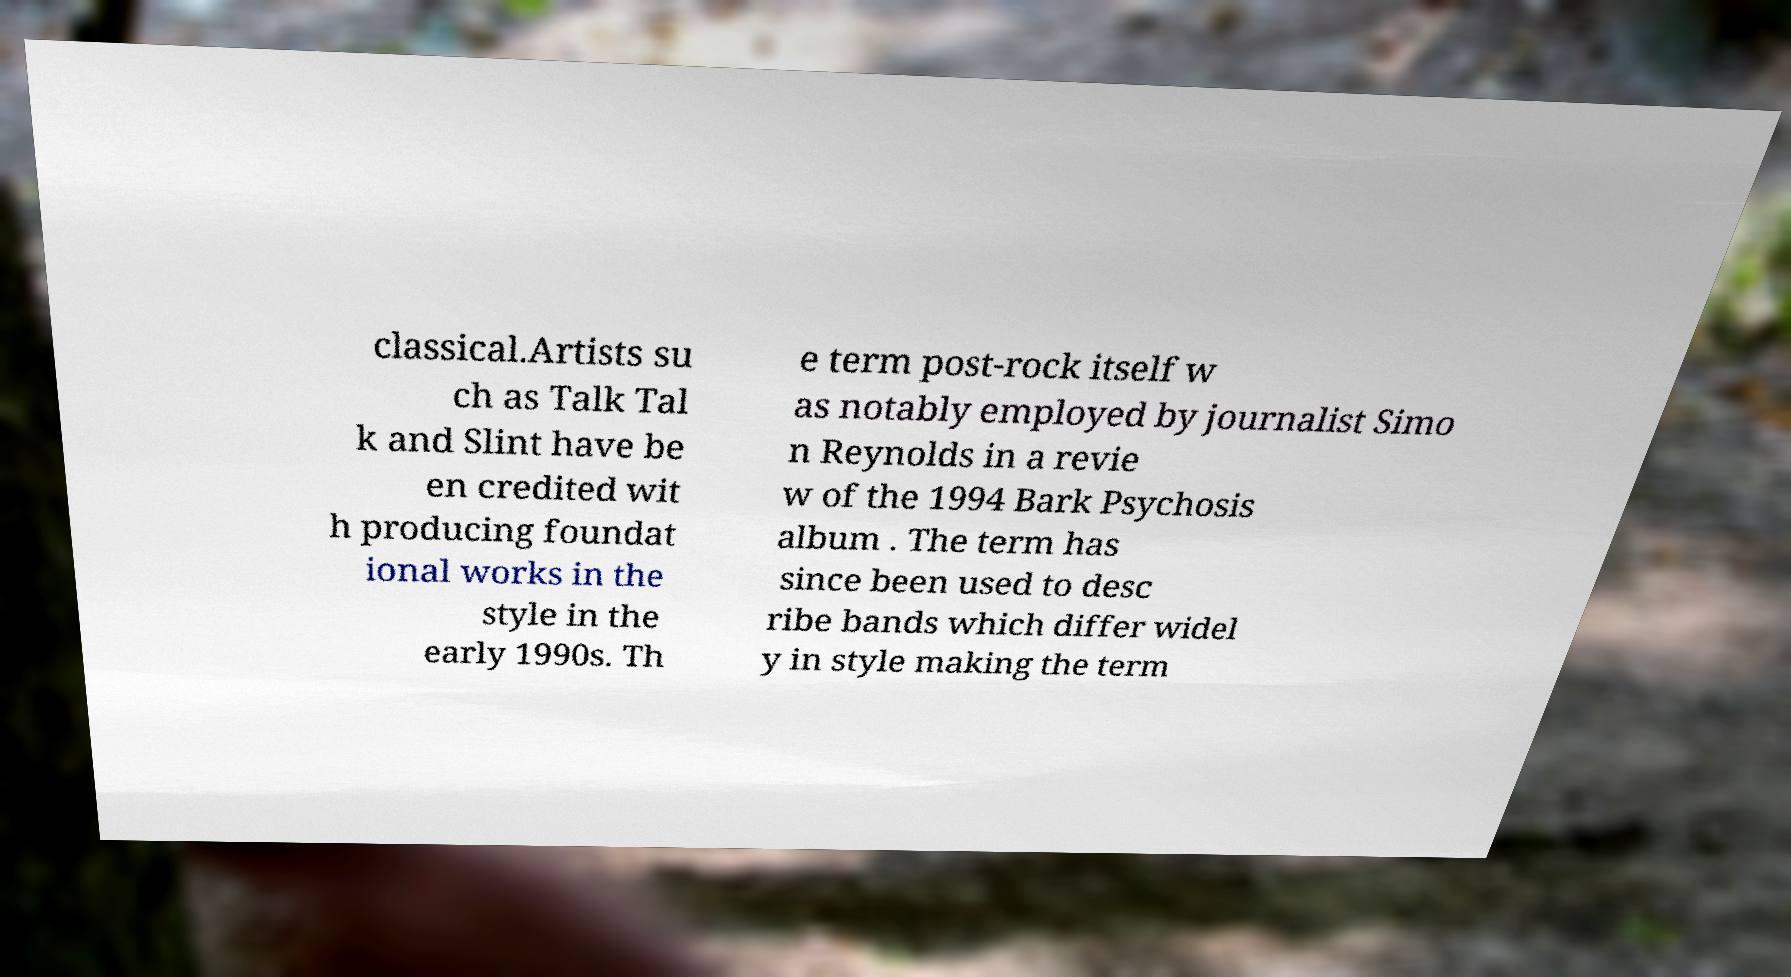Can you read and provide the text displayed in the image?This photo seems to have some interesting text. Can you extract and type it out for me? classical.Artists su ch as Talk Tal k and Slint have be en credited wit h producing foundat ional works in the style in the early 1990s. Th e term post-rock itself w as notably employed by journalist Simo n Reynolds in a revie w of the 1994 Bark Psychosis album . The term has since been used to desc ribe bands which differ widel y in style making the term 